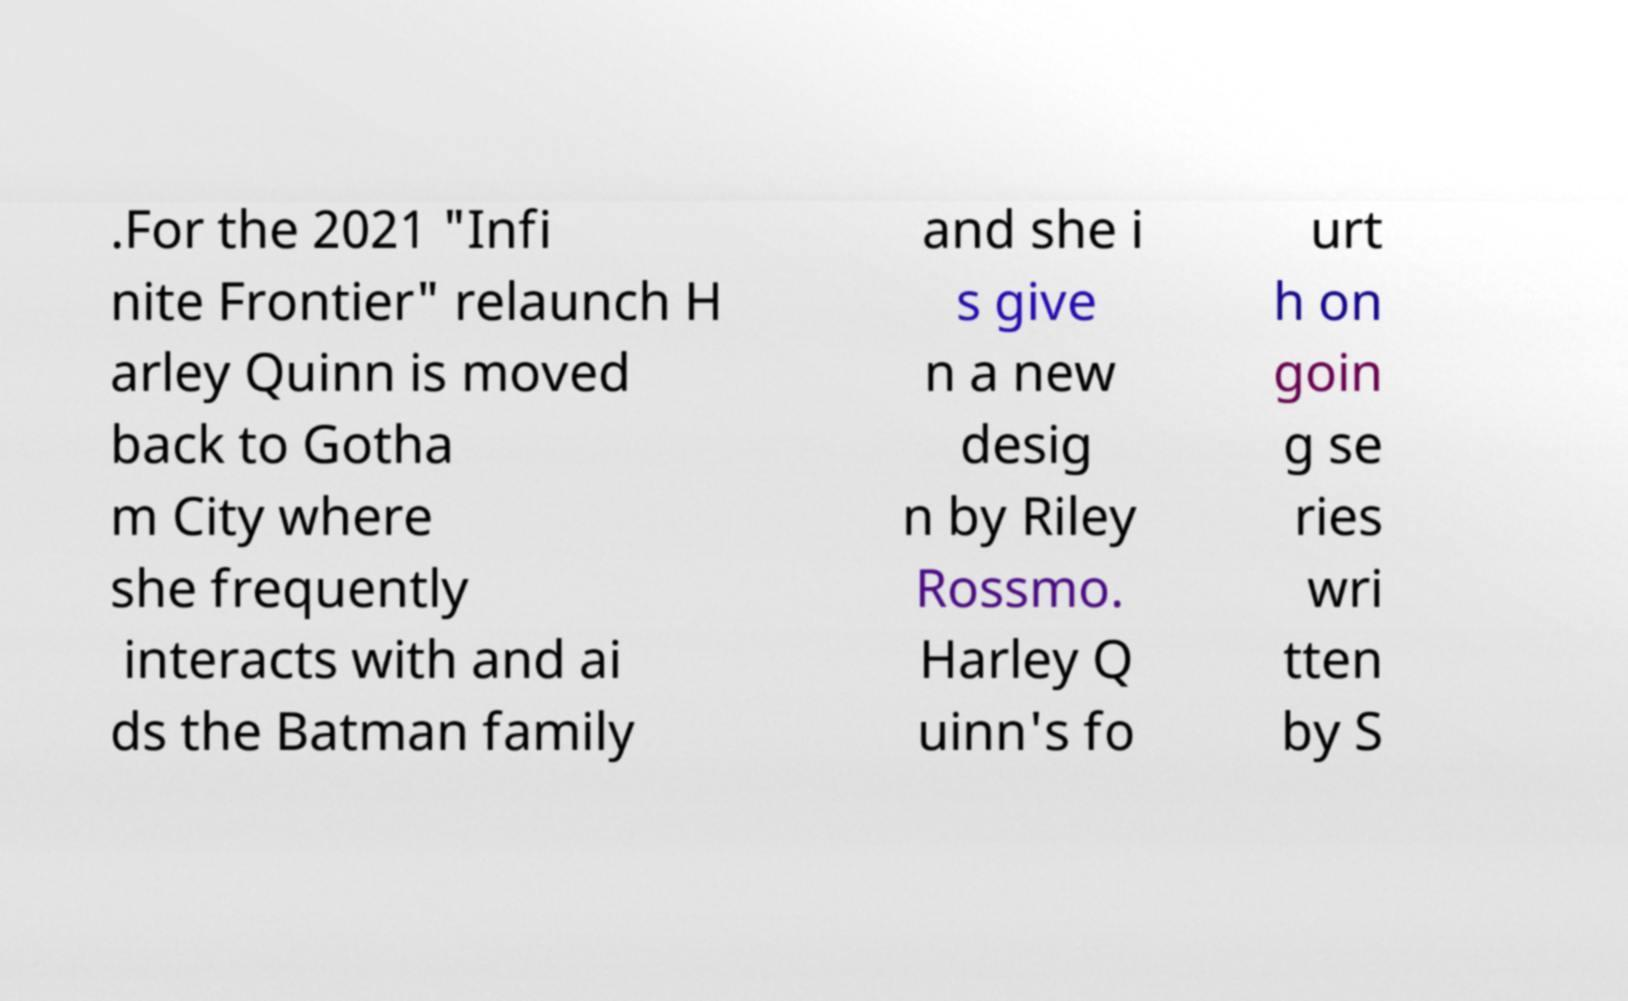Could you assist in decoding the text presented in this image and type it out clearly? .For the 2021 "Infi nite Frontier" relaunch H arley Quinn is moved back to Gotha m City where she frequently interacts with and ai ds the Batman family and she i s give n a new desig n by Riley Rossmo. Harley Q uinn's fo urt h on goin g se ries wri tten by S 